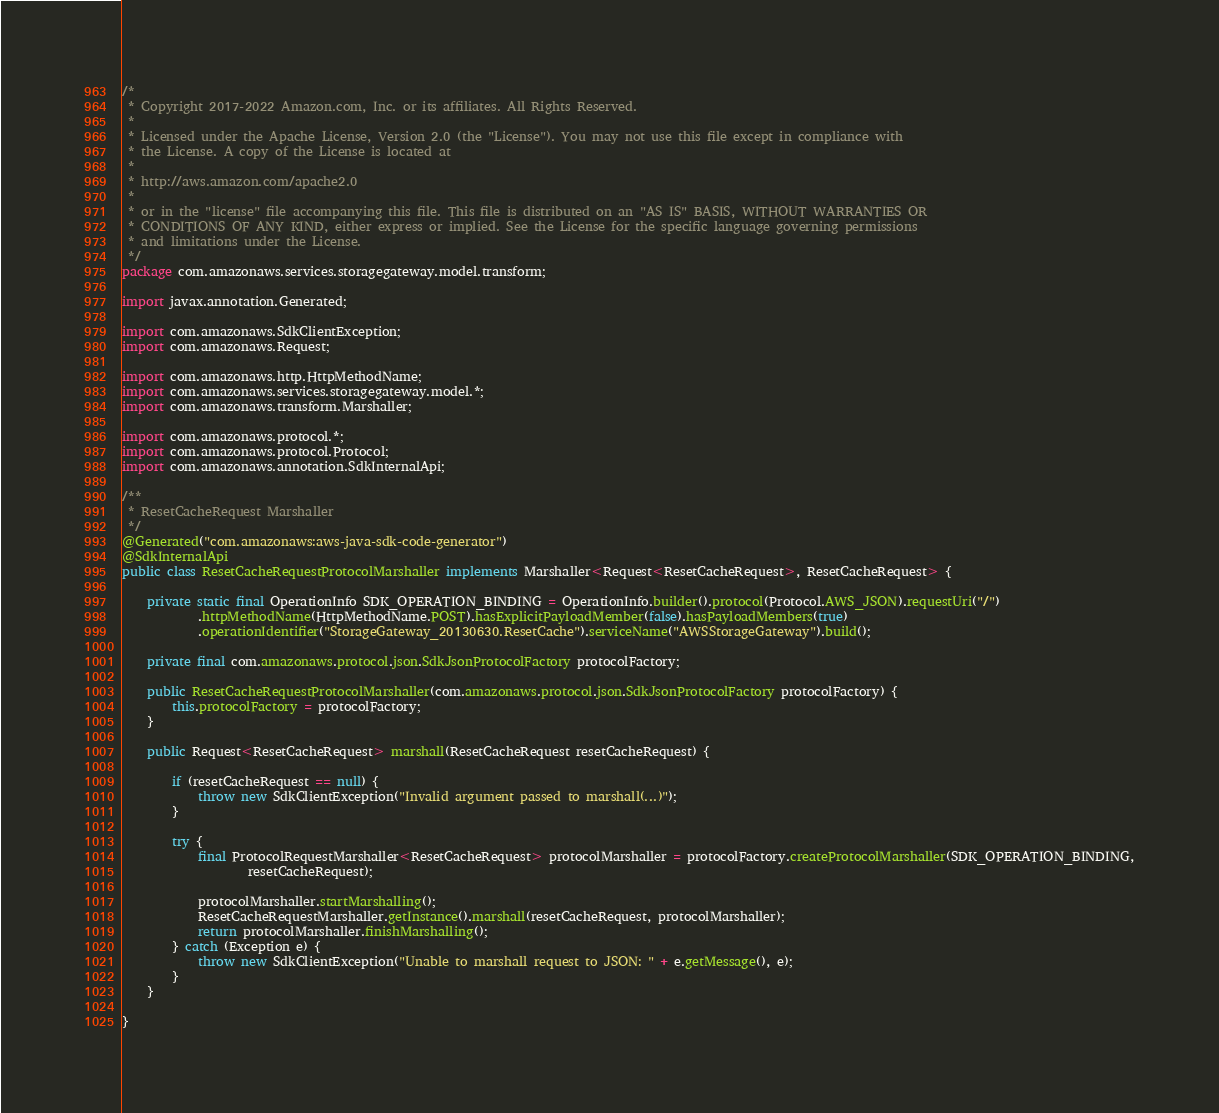Convert code to text. <code><loc_0><loc_0><loc_500><loc_500><_Java_>/*
 * Copyright 2017-2022 Amazon.com, Inc. or its affiliates. All Rights Reserved.
 * 
 * Licensed under the Apache License, Version 2.0 (the "License"). You may not use this file except in compliance with
 * the License. A copy of the License is located at
 * 
 * http://aws.amazon.com/apache2.0
 * 
 * or in the "license" file accompanying this file. This file is distributed on an "AS IS" BASIS, WITHOUT WARRANTIES OR
 * CONDITIONS OF ANY KIND, either express or implied. See the License for the specific language governing permissions
 * and limitations under the License.
 */
package com.amazonaws.services.storagegateway.model.transform;

import javax.annotation.Generated;

import com.amazonaws.SdkClientException;
import com.amazonaws.Request;

import com.amazonaws.http.HttpMethodName;
import com.amazonaws.services.storagegateway.model.*;
import com.amazonaws.transform.Marshaller;

import com.amazonaws.protocol.*;
import com.amazonaws.protocol.Protocol;
import com.amazonaws.annotation.SdkInternalApi;

/**
 * ResetCacheRequest Marshaller
 */
@Generated("com.amazonaws:aws-java-sdk-code-generator")
@SdkInternalApi
public class ResetCacheRequestProtocolMarshaller implements Marshaller<Request<ResetCacheRequest>, ResetCacheRequest> {

    private static final OperationInfo SDK_OPERATION_BINDING = OperationInfo.builder().protocol(Protocol.AWS_JSON).requestUri("/")
            .httpMethodName(HttpMethodName.POST).hasExplicitPayloadMember(false).hasPayloadMembers(true)
            .operationIdentifier("StorageGateway_20130630.ResetCache").serviceName("AWSStorageGateway").build();

    private final com.amazonaws.protocol.json.SdkJsonProtocolFactory protocolFactory;

    public ResetCacheRequestProtocolMarshaller(com.amazonaws.protocol.json.SdkJsonProtocolFactory protocolFactory) {
        this.protocolFactory = protocolFactory;
    }

    public Request<ResetCacheRequest> marshall(ResetCacheRequest resetCacheRequest) {

        if (resetCacheRequest == null) {
            throw new SdkClientException("Invalid argument passed to marshall(...)");
        }

        try {
            final ProtocolRequestMarshaller<ResetCacheRequest> protocolMarshaller = protocolFactory.createProtocolMarshaller(SDK_OPERATION_BINDING,
                    resetCacheRequest);

            protocolMarshaller.startMarshalling();
            ResetCacheRequestMarshaller.getInstance().marshall(resetCacheRequest, protocolMarshaller);
            return protocolMarshaller.finishMarshalling();
        } catch (Exception e) {
            throw new SdkClientException("Unable to marshall request to JSON: " + e.getMessage(), e);
        }
    }

}
</code> 